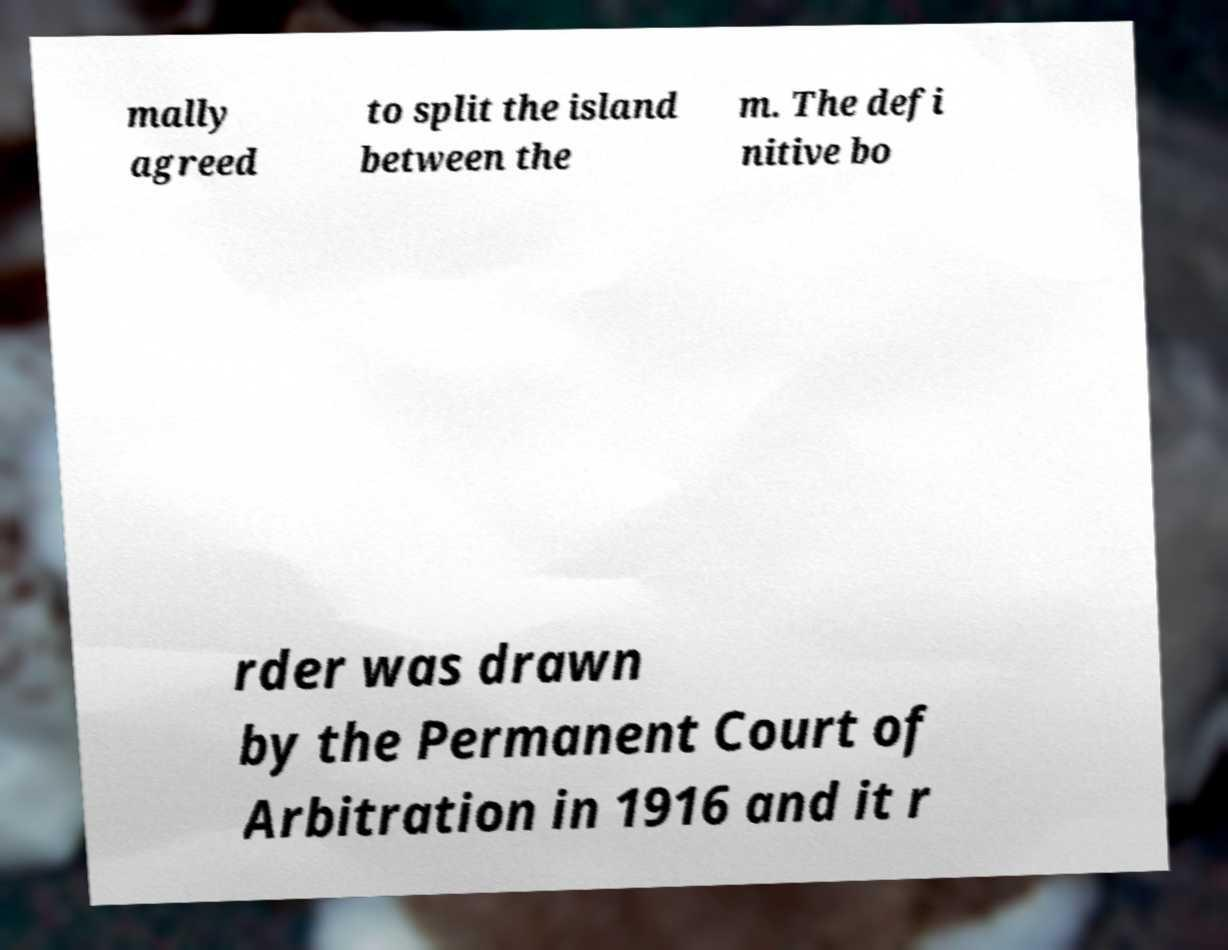Could you extract and type out the text from this image? mally agreed to split the island between the m. The defi nitive bo rder was drawn by the Permanent Court of Arbitration in 1916 and it r 